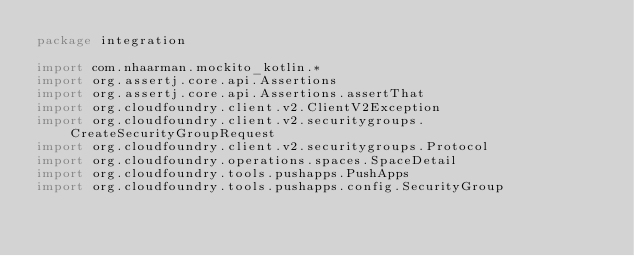Convert code to text. <code><loc_0><loc_0><loc_500><loc_500><_Kotlin_>package integration

import com.nhaarman.mockito_kotlin.*
import org.assertj.core.api.Assertions
import org.assertj.core.api.Assertions.assertThat
import org.cloudfoundry.client.v2.ClientV2Exception
import org.cloudfoundry.client.v2.securitygroups.CreateSecurityGroupRequest
import org.cloudfoundry.client.v2.securitygroups.Protocol
import org.cloudfoundry.operations.spaces.SpaceDetail
import org.cloudfoundry.tools.pushapps.PushApps
import org.cloudfoundry.tools.pushapps.config.SecurityGroup</code> 